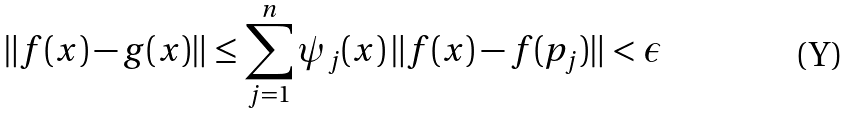Convert formula to latex. <formula><loc_0><loc_0><loc_500><loc_500>\| f ( x ) - g ( x ) \| \leq \sum _ { j = 1 } ^ { n } \psi _ { j } ( x ) \, \| f ( x ) - f ( p _ { j } ) \| < \epsilon</formula> 